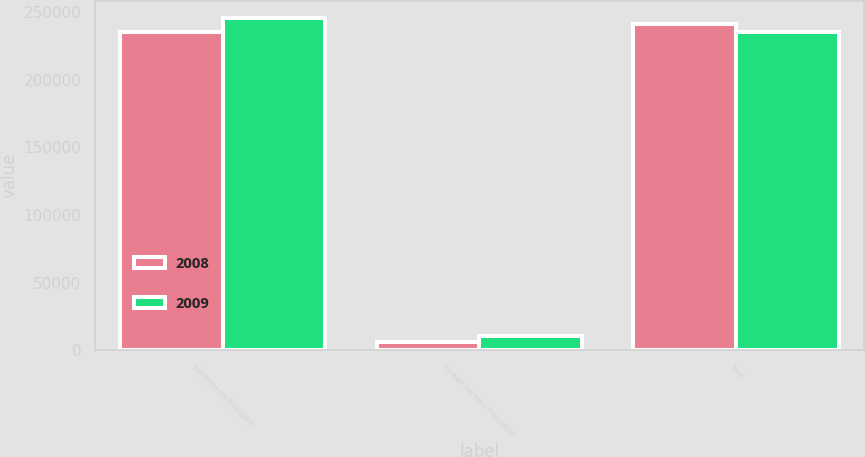Convert chart to OTSL. <chart><loc_0><loc_0><loc_500><loc_500><stacked_bar_chart><ecel><fcel>Indefinite-life intangible<fcel>Foreign currency translation<fcel>Total<nl><fcel>2008<fcel>235610<fcel>5953<fcel>241563<nl><fcel>2009<fcel>246014<fcel>10404<fcel>235610<nl></chart> 